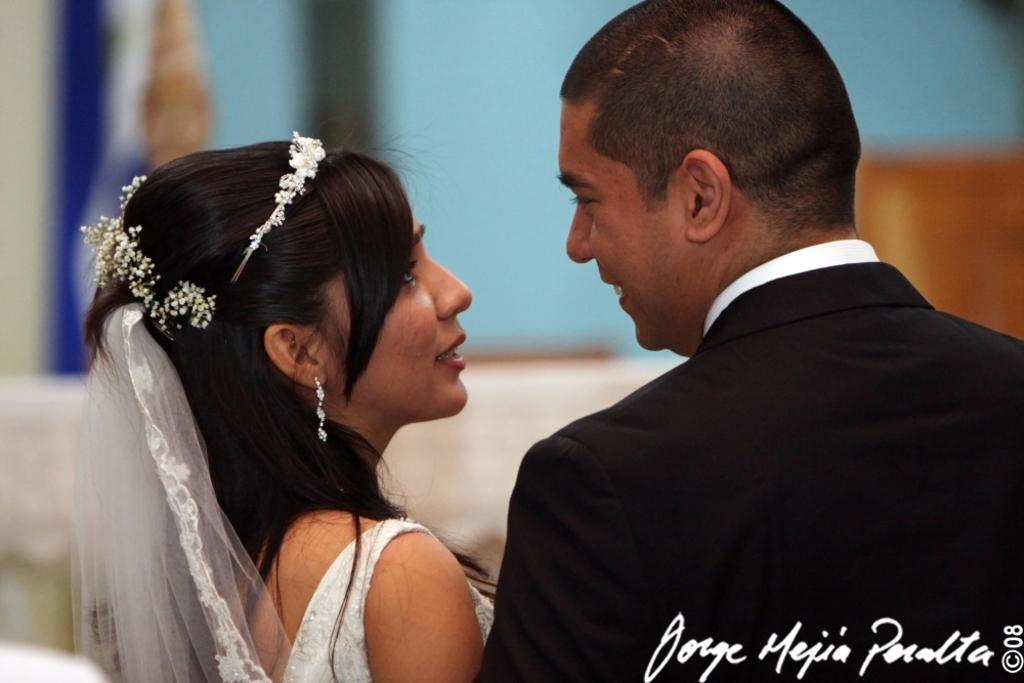Who is present in the image? There is a couple in the image. What are the couple doing in the image? The couple is looking at each other. Can you describe the background of the image? The background of the couple is blurred. What type of bear can be seen interacting with the couple in the image? There is no bear present in the image; it features a couple looking at each other with a blurred background. What language are the couple speaking in the image? The image does not provide any information about the language the couple is speaking. 